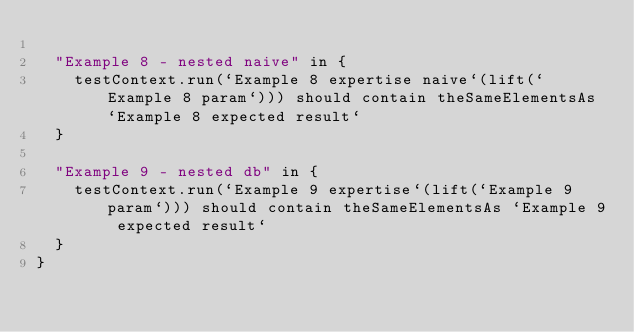<code> <loc_0><loc_0><loc_500><loc_500><_Scala_>
  "Example 8 - nested naive" in {
    testContext.run(`Example 8 expertise naive`(lift(`Example 8 param`))) should contain theSameElementsAs `Example 8 expected result`
  }

  "Example 9 - nested db" in {
    testContext.run(`Example 9 expertise`(lift(`Example 9 param`))) should contain theSameElementsAs `Example 9 expected result`
  }
}
</code> 